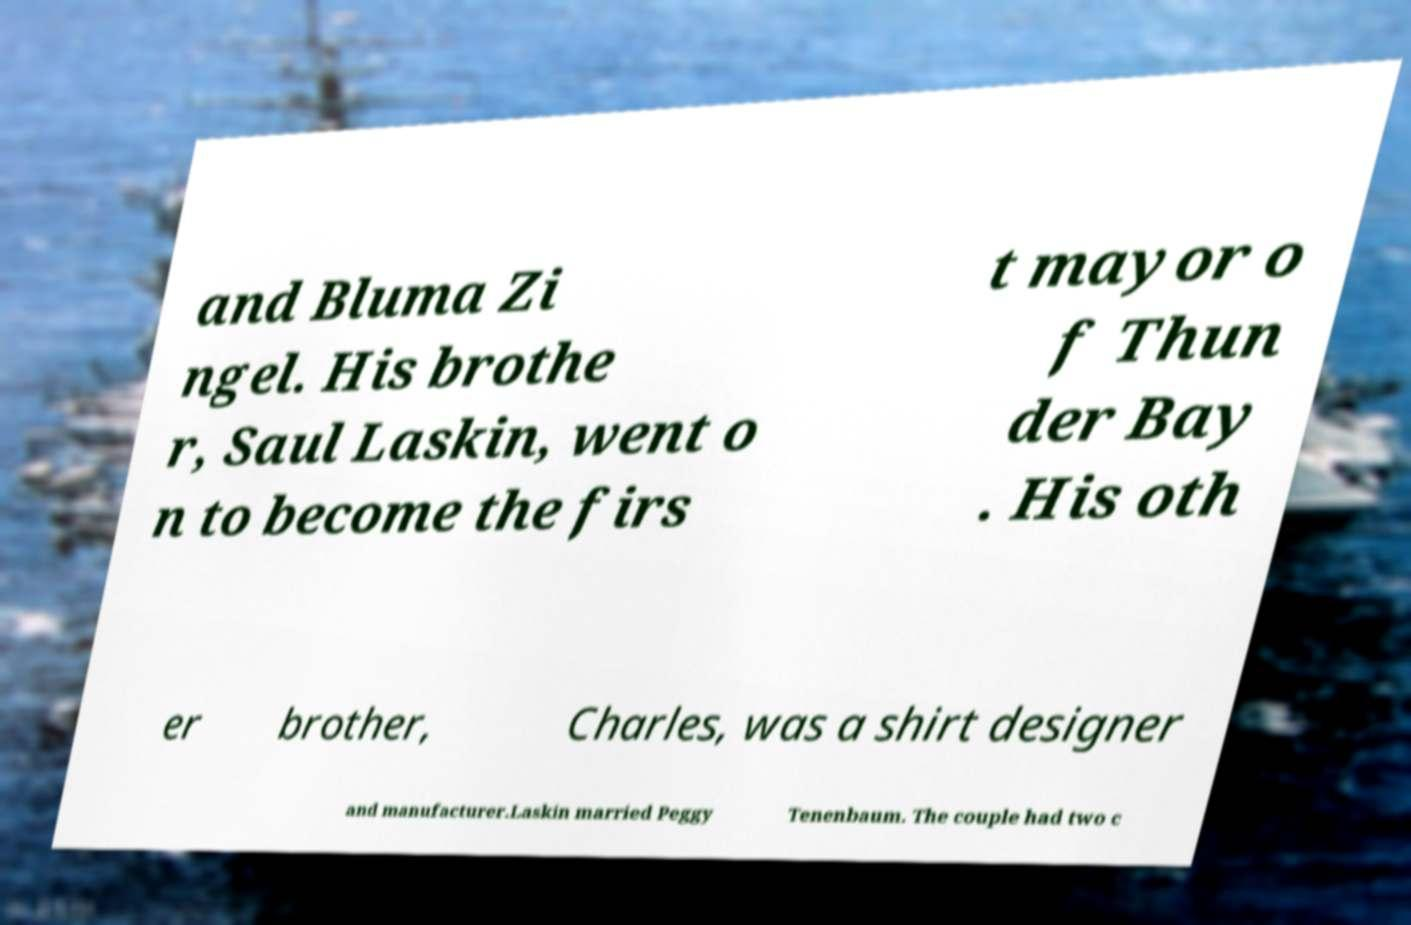Could you extract and type out the text from this image? and Bluma Zi ngel. His brothe r, Saul Laskin, went o n to become the firs t mayor o f Thun der Bay . His oth er brother, Charles, was a shirt designer and manufacturer.Laskin married Peggy Tenenbaum. The couple had two c 